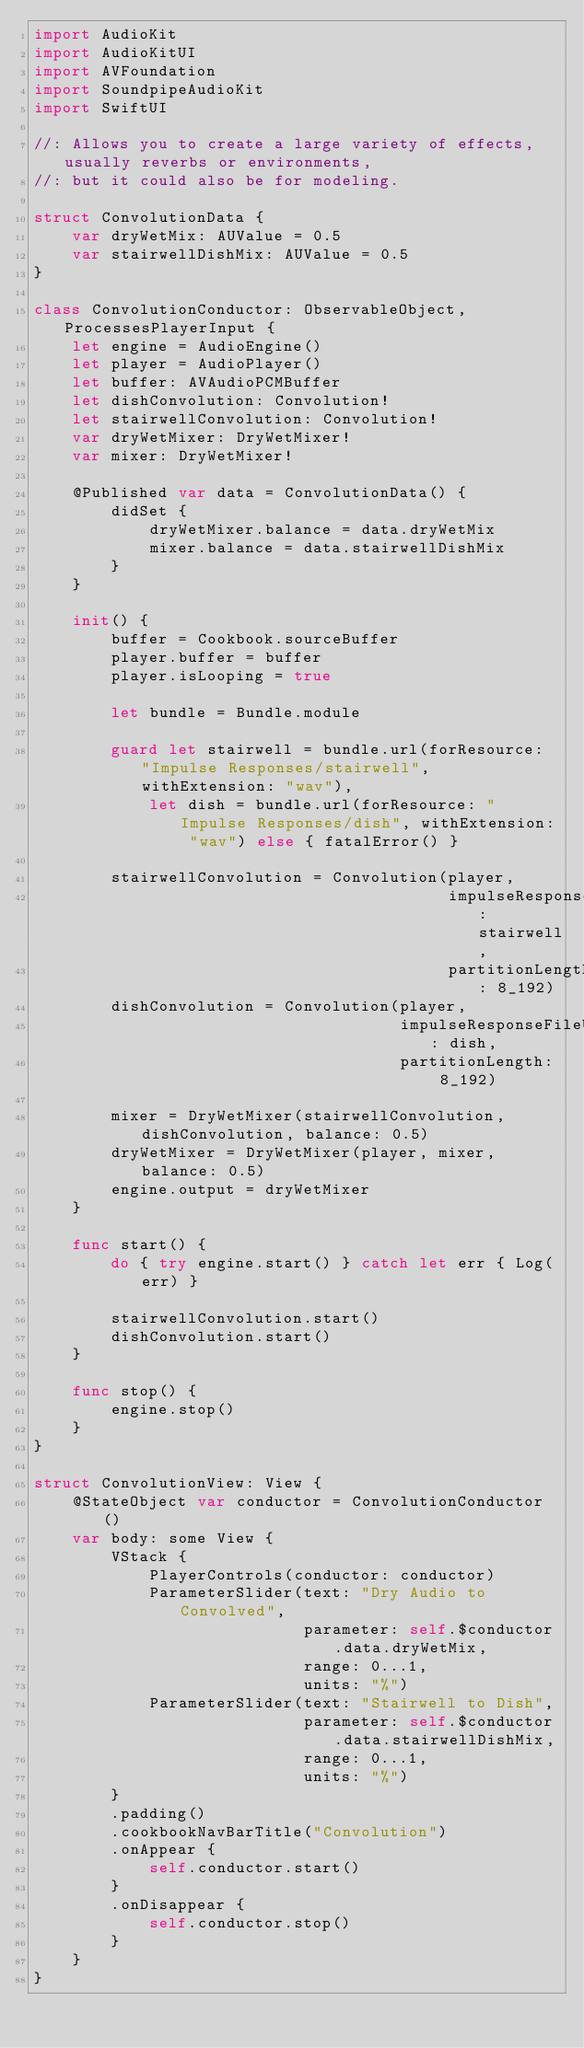Convert code to text. <code><loc_0><loc_0><loc_500><loc_500><_Swift_>import AudioKit
import AudioKitUI
import AVFoundation
import SoundpipeAudioKit
import SwiftUI

//: Allows you to create a large variety of effects, usually reverbs or environments,
//: but it could also be for modeling.

struct ConvolutionData {
    var dryWetMix: AUValue = 0.5
    var stairwellDishMix: AUValue = 0.5
}

class ConvolutionConductor: ObservableObject, ProcessesPlayerInput {
    let engine = AudioEngine()
    let player = AudioPlayer()
    let buffer: AVAudioPCMBuffer
    let dishConvolution: Convolution!
    let stairwellConvolution: Convolution!
    var dryWetMixer: DryWetMixer!
    var mixer: DryWetMixer!

    @Published var data = ConvolutionData() {
        didSet {
            dryWetMixer.balance = data.dryWetMix
            mixer.balance = data.stairwellDishMix
        }
    }

    init() {
        buffer = Cookbook.sourceBuffer
        player.buffer = buffer
        player.isLooping = true

        let bundle = Bundle.module

        guard let stairwell = bundle.url(forResource: "Impulse Responses/stairwell", withExtension: "wav"),
            let dish = bundle.url(forResource: "Impulse Responses/dish", withExtension: "wav") else { fatalError() }

        stairwellConvolution = Convolution(player,
                                           impulseResponseFileURL: stairwell,
                                           partitionLength: 8_192)
        dishConvolution = Convolution(player,
                                      impulseResponseFileURL: dish,
                                      partitionLength: 8_192)

        mixer = DryWetMixer(stairwellConvolution, dishConvolution, balance: 0.5)
        dryWetMixer = DryWetMixer(player, mixer, balance: 0.5)
        engine.output = dryWetMixer
    }

    func start() {
        do { try engine.start() } catch let err { Log(err) }

        stairwellConvolution.start()
        dishConvolution.start()
    }

    func stop() {
        engine.stop()
    }
}

struct ConvolutionView: View {
    @StateObject var conductor = ConvolutionConductor()
    var body: some View {
        VStack {
            PlayerControls(conductor: conductor)
            ParameterSlider(text: "Dry Audio to Convolved",
                            parameter: self.$conductor.data.dryWetMix,
                            range: 0...1,
                            units: "%")
            ParameterSlider(text: "Stairwell to Dish",
                            parameter: self.$conductor.data.stairwellDishMix,
                            range: 0...1,
                            units: "%")
        }
        .padding()
        .cookbookNavBarTitle("Convolution")
        .onAppear {
            self.conductor.start()
        }
        .onDisappear {
            self.conductor.stop()
        }
    }
}
</code> 